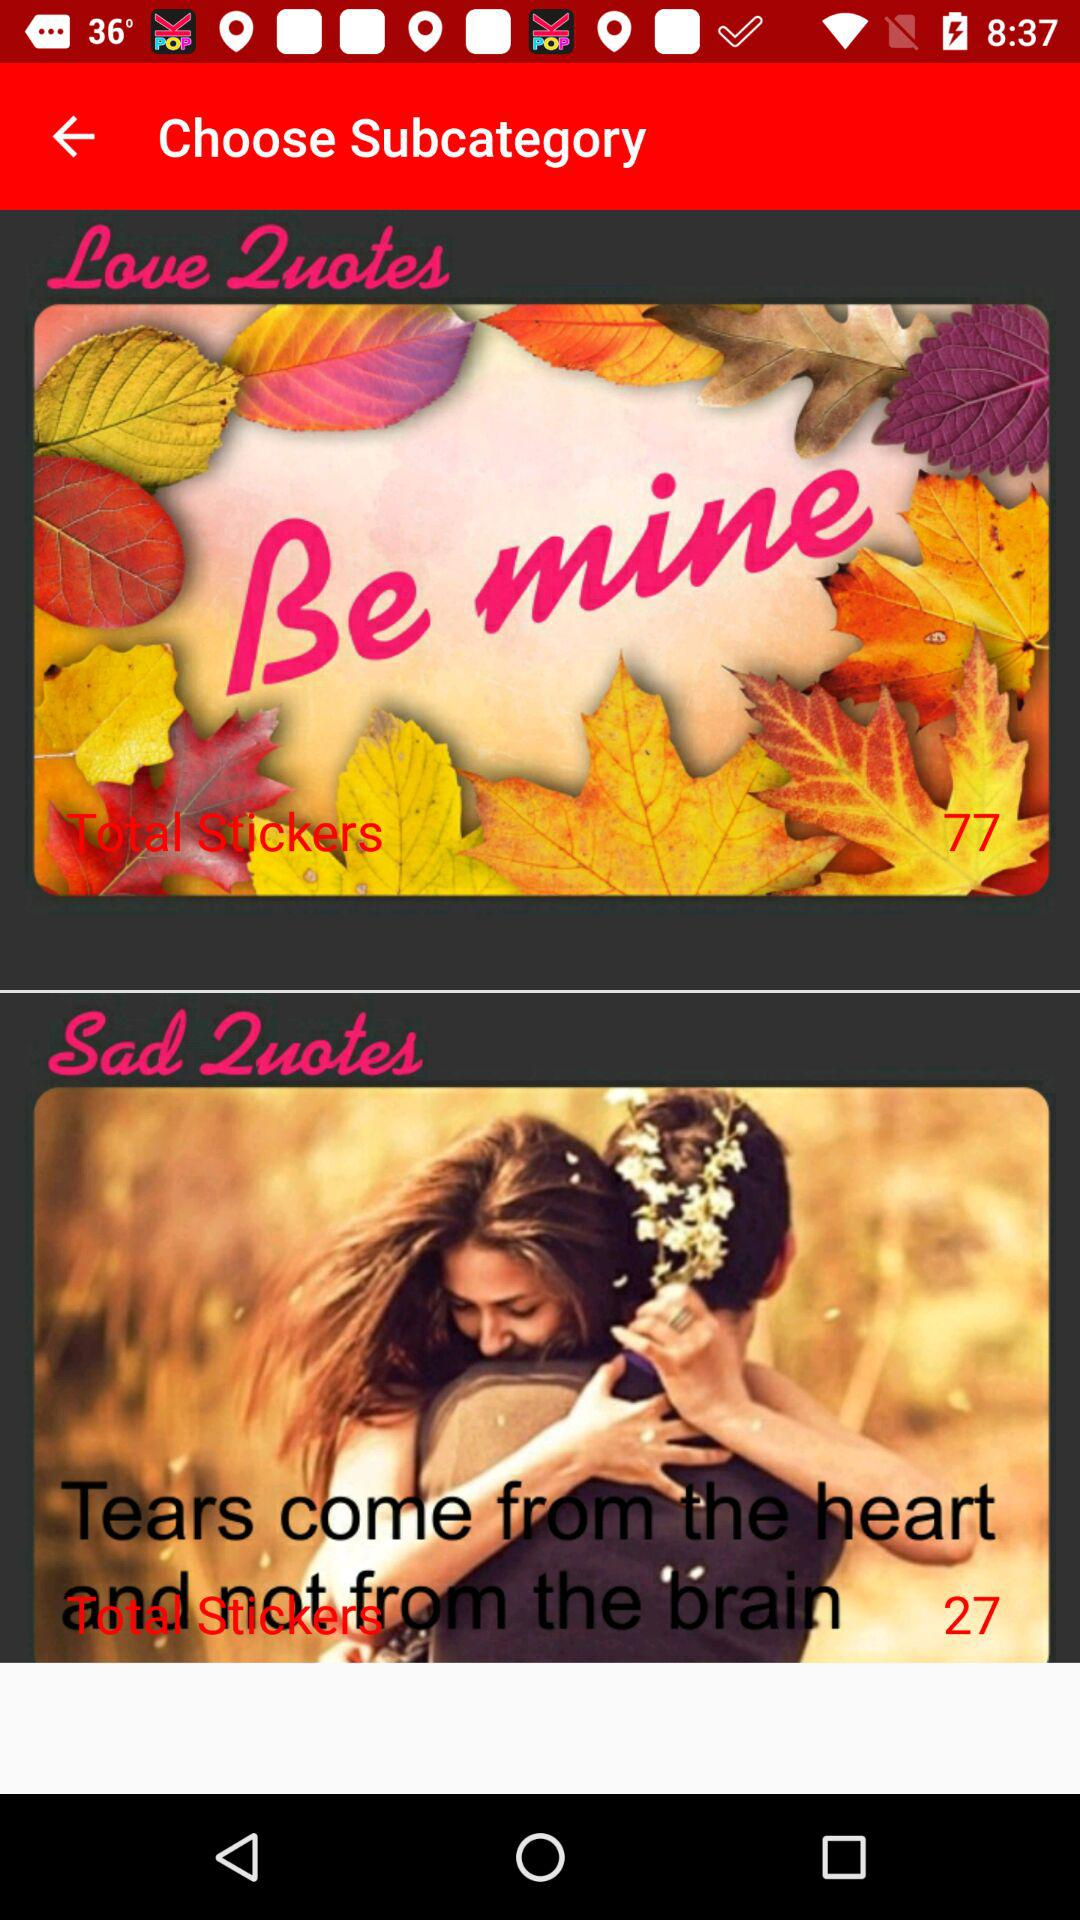How many stickers are there for love quotes? There are 77 stickers for love quotes. 